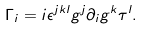Convert formula to latex. <formula><loc_0><loc_0><loc_500><loc_500>\Gamma _ { i } = i \epsilon ^ { j k l } g ^ { j } \partial _ { i } g ^ { k } \tau ^ { l } .</formula> 